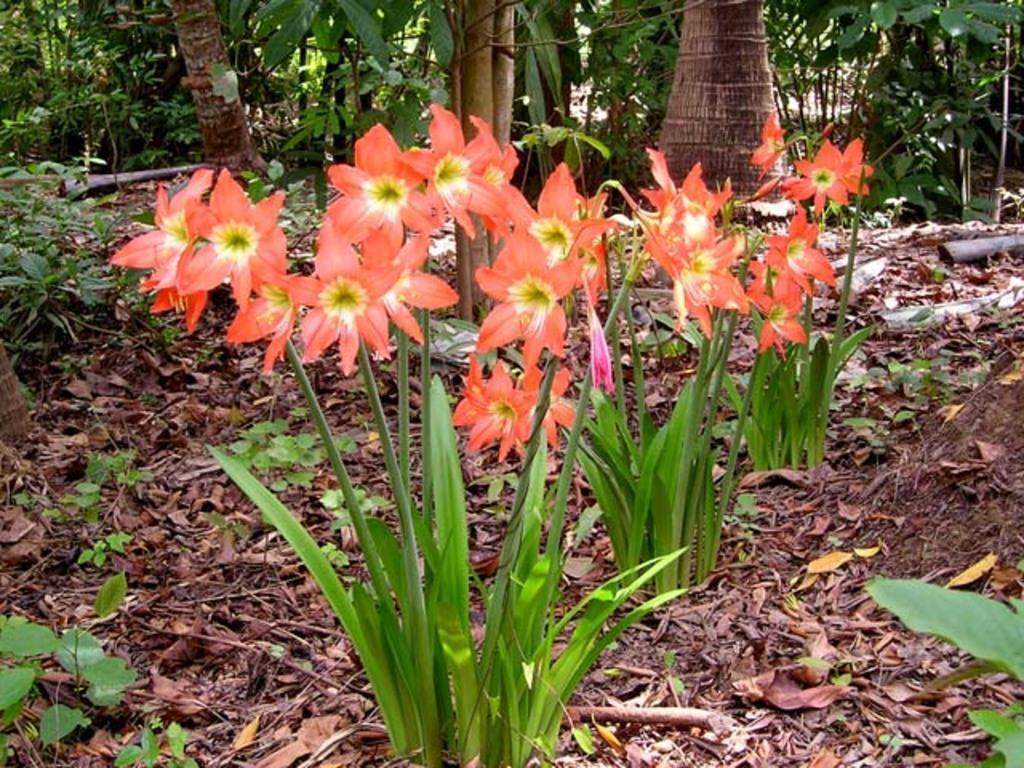Could you give a brief overview of what you see in this image? Here in this picture we can see flowers present on plants over there and we can also see dry leaves and trees and other plants present all over there. 